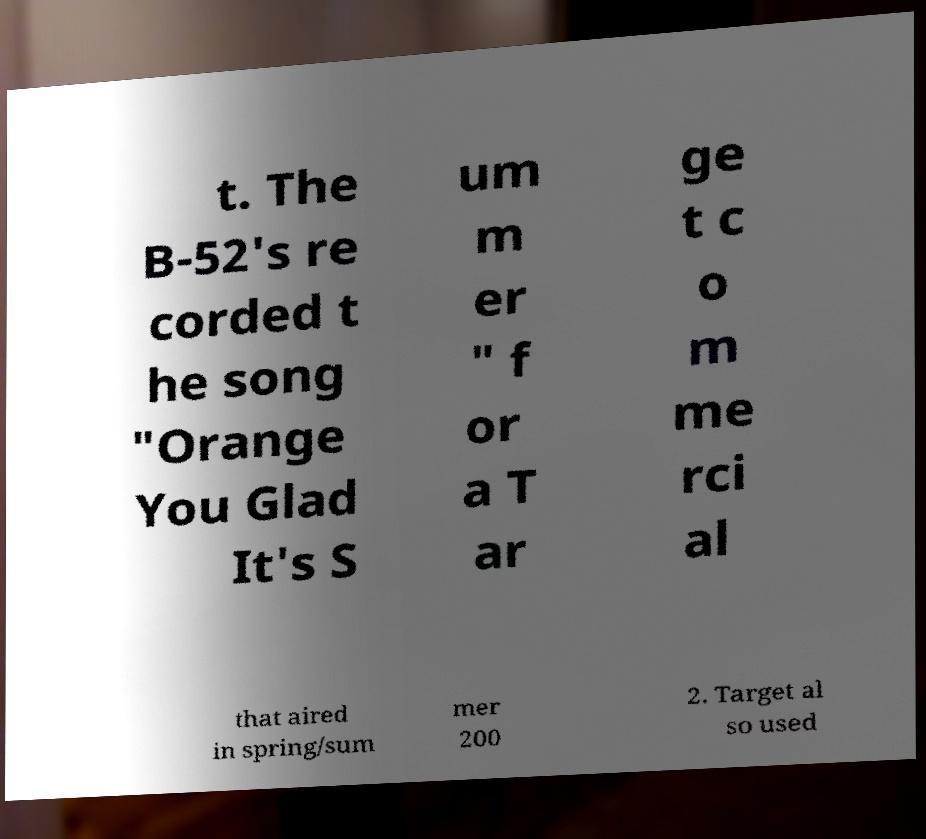Please read and relay the text visible in this image. What does it say? t. The B-52's re corded t he song "Orange You Glad It's S um m er " f or a T ar ge t c o m me rci al that aired in spring/sum mer 200 2. Target al so used 